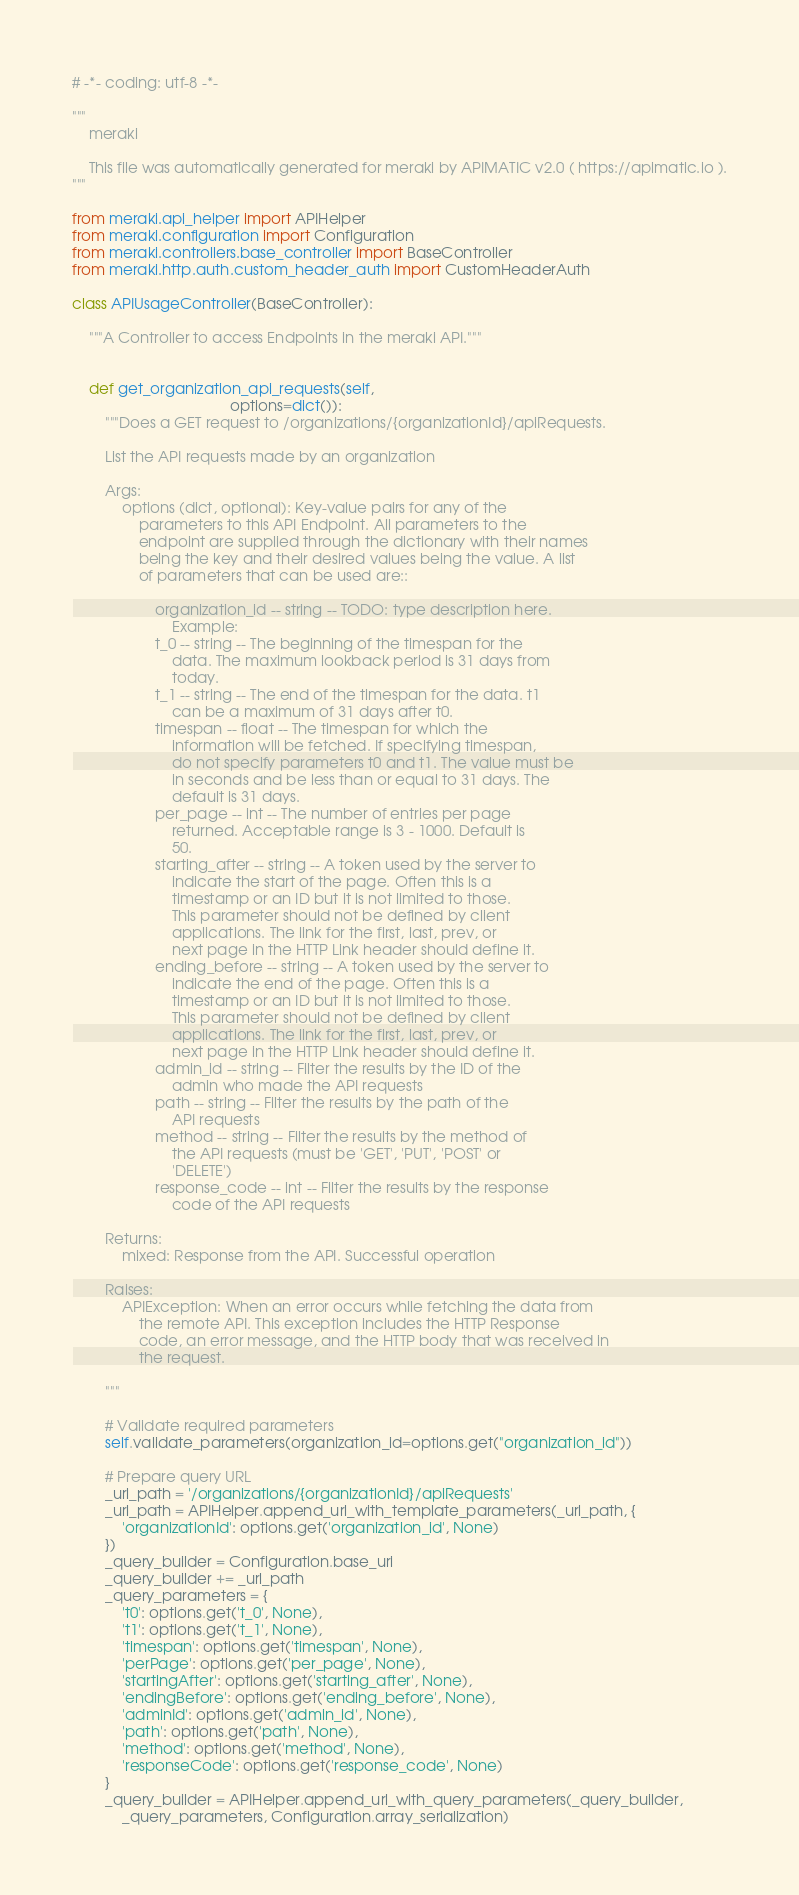Convert code to text. <code><loc_0><loc_0><loc_500><loc_500><_Python_># -*- coding: utf-8 -*-

"""
    meraki

    This file was automatically generated for meraki by APIMATIC v2.0 ( https://apimatic.io ).
"""

from meraki.api_helper import APIHelper
from meraki.configuration import Configuration
from meraki.controllers.base_controller import BaseController
from meraki.http.auth.custom_header_auth import CustomHeaderAuth

class APIUsageController(BaseController):

    """A Controller to access Endpoints in the meraki API."""


    def get_organization_api_requests(self,
                                      options=dict()):
        """Does a GET request to /organizations/{organizationId}/apiRequests.

        List the API requests made by an organization

        Args:
            options (dict, optional): Key-value pairs for any of the
                parameters to this API Endpoint. All parameters to the
                endpoint are supplied through the dictionary with their names
                being the key and their desired values being the value. A list
                of parameters that can be used are::

                    organization_id -- string -- TODO: type description here.
                        Example: 
                    t_0 -- string -- The beginning of the timespan for the
                        data. The maximum lookback period is 31 days from
                        today.
                    t_1 -- string -- The end of the timespan for the data. t1
                        can be a maximum of 31 days after t0.
                    timespan -- float -- The timespan for which the
                        information will be fetched. If specifying timespan,
                        do not specify parameters t0 and t1. The value must be
                        in seconds and be less than or equal to 31 days. The
                        default is 31 days.
                    per_page -- int -- The number of entries per page
                        returned. Acceptable range is 3 - 1000. Default is
                        50.
                    starting_after -- string -- A token used by the server to
                        indicate the start of the page. Often this is a
                        timestamp or an ID but it is not limited to those.
                        This parameter should not be defined by client
                        applications. The link for the first, last, prev, or
                        next page in the HTTP Link header should define it.
                    ending_before -- string -- A token used by the server to
                        indicate the end of the page. Often this is a
                        timestamp or an ID but it is not limited to those.
                        This parameter should not be defined by client
                        applications. The link for the first, last, prev, or
                        next page in the HTTP Link header should define it.
                    admin_id -- string -- Filter the results by the ID of the
                        admin who made the API requests
                    path -- string -- Filter the results by the path of the
                        API requests
                    method -- string -- Filter the results by the method of
                        the API requests (must be 'GET', 'PUT', 'POST' or
                        'DELETE')
                    response_code -- int -- Filter the results by the response
                        code of the API requests

        Returns:
            mixed: Response from the API. Successful operation

        Raises:
            APIException: When an error occurs while fetching the data from
                the remote API. This exception includes the HTTP Response
                code, an error message, and the HTTP body that was received in
                the request.

        """

        # Validate required parameters
        self.validate_parameters(organization_id=options.get("organization_id"))

        # Prepare query URL
        _url_path = '/organizations/{organizationId}/apiRequests'
        _url_path = APIHelper.append_url_with_template_parameters(_url_path, { 
            'organizationId': options.get('organization_id', None)
        })
        _query_builder = Configuration.base_uri
        _query_builder += _url_path
        _query_parameters = {
            't0': options.get('t_0', None),
            't1': options.get('t_1', None),
            'timespan': options.get('timespan', None),
            'perPage': options.get('per_page', None),
            'startingAfter': options.get('starting_after', None),
            'endingBefore': options.get('ending_before', None),
            'adminId': options.get('admin_id', None),
            'path': options.get('path', None),
            'method': options.get('method', None),
            'responseCode': options.get('response_code', None)
        }
        _query_builder = APIHelper.append_url_with_query_parameters(_query_builder,
            _query_parameters, Configuration.array_serialization)</code> 